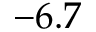<formula> <loc_0><loc_0><loc_500><loc_500>- 6 . 7</formula> 